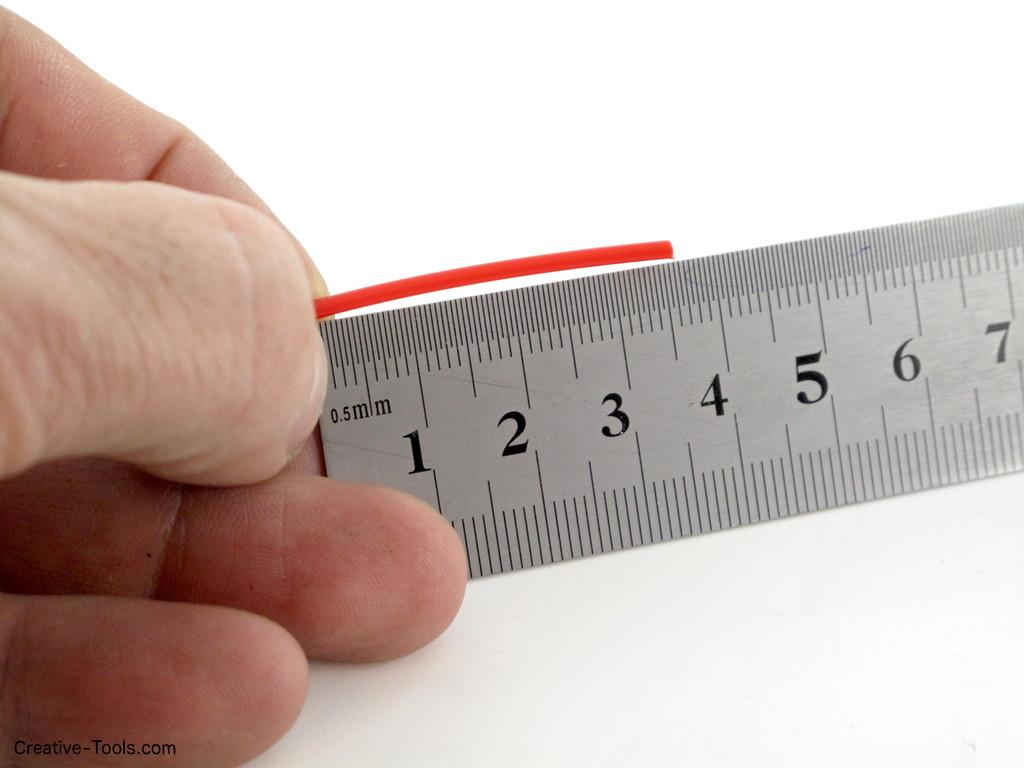<image>
Render a clear and concise summary of the photo. a ruler with mm on it and the numbers 1-7 